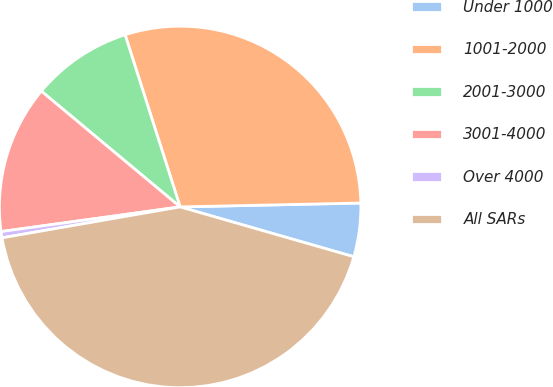Convert chart. <chart><loc_0><loc_0><loc_500><loc_500><pie_chart><fcel>Under 1000<fcel>1001-2000<fcel>2001-3000<fcel>3001-4000<fcel>Over 4000<fcel>All SARs<nl><fcel>4.79%<fcel>29.58%<fcel>9.01%<fcel>13.24%<fcel>0.56%<fcel>42.81%<nl></chart> 